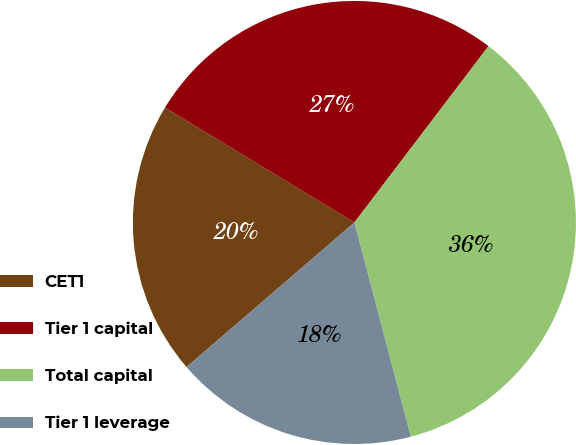<chart> <loc_0><loc_0><loc_500><loc_500><pie_chart><fcel>CET1<fcel>Tier 1 capital<fcel>Total capital<fcel>Tier 1 leverage<nl><fcel>20.0%<fcel>26.67%<fcel>35.56%<fcel>17.78%<nl></chart> 